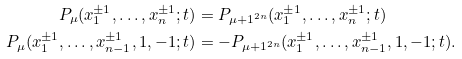Convert formula to latex. <formula><loc_0><loc_0><loc_500><loc_500>P _ { \mu } ( x _ { 1 } ^ { \pm 1 } , \dots , x _ { n } ^ { \pm 1 } ; t ) & = P _ { \mu + 1 ^ { 2 n } } ( x _ { 1 } ^ { \pm 1 } , \dots , x _ { n } ^ { \pm 1 } ; t ) \\ P _ { \mu } ( x _ { 1 } ^ { \pm 1 } , \dots , x _ { n - 1 } ^ { \pm 1 } , 1 , - 1 ; t ) & = - P _ { \mu + 1 ^ { 2 n } } ( x _ { 1 } ^ { \pm 1 } , \dots , x _ { n - 1 } ^ { \pm 1 } , 1 , - 1 ; t ) . \\</formula> 